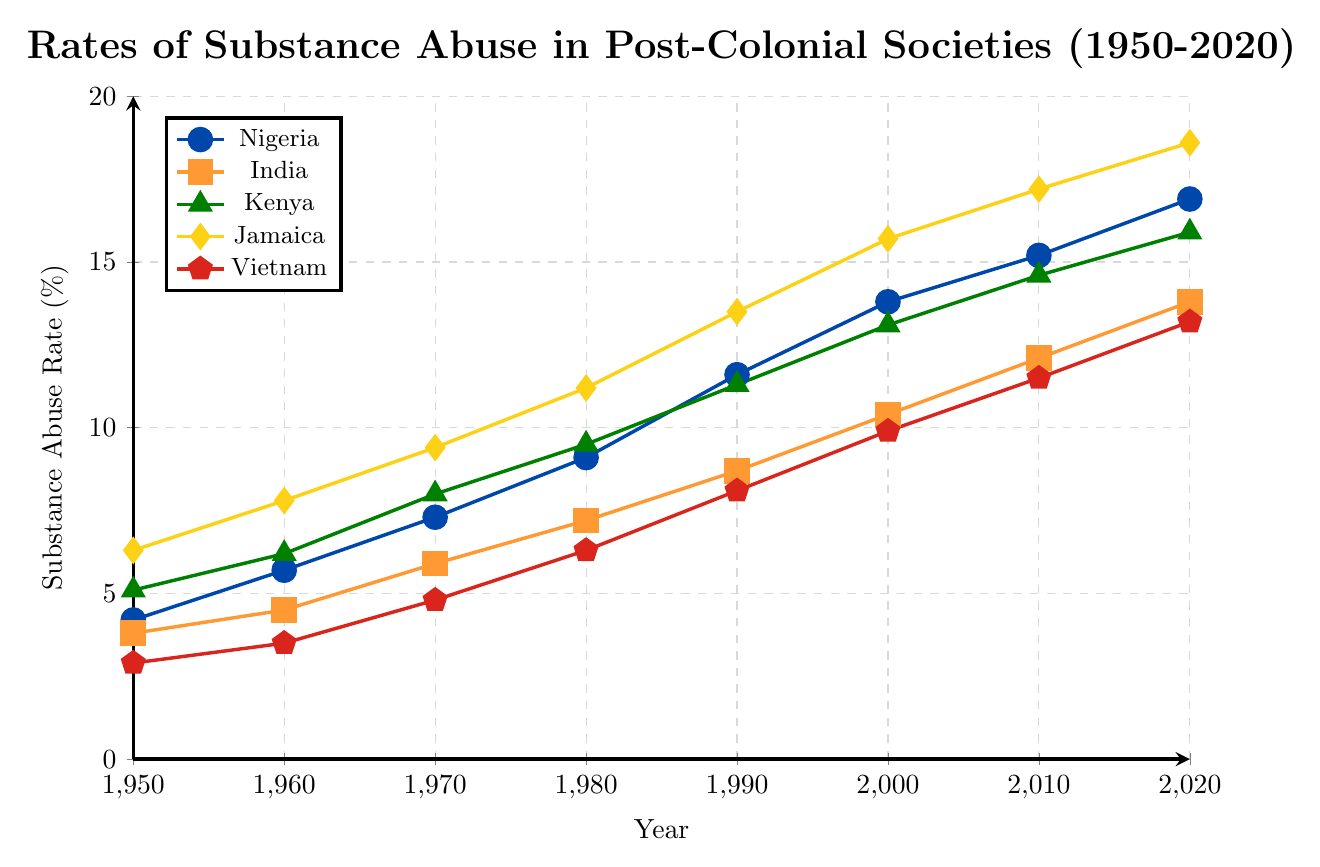What year did Nigeria surpass a substance abuse rate of 10%? Look at the line for Nigeria, indicated by blue circles, and find the year when it crosses the 10% mark on the y-axis. This happens between 1980 and 1990.
Answer: 1990 Which country had the highest substance abuse rate in 1960? Examine the data points for 1960 across all countries. The highest value is represented by the yellow diamond (Jamaica) at 7.8%.
Answer: Jamaica Which country shows the steepest increase in substance abuse rates from 1950 to 2020? Evaluate the slopes of the lines for each country over the entire time period. The line with the steepest incline, indicating the fastest increase, is Jamaica (yellow diamonds).
Answer: Jamaica How much did the substance abuse rate in India increase from 1980 to 2020 compared to Nigeria? Calculate the difference for both countries. For India, it's 13.8% - 7.2% = 6.6%. For Nigeria, it's 16.9% - 9.1% = 7.8%. Compare the two values.
Answer: Nigeria had a higher increase What is the median substance abuse rate in 2000 for all countries? List the 2000 values: 13.8 (Nigeria), 10.4 (India), 13.1 (Kenya), 15.7 (Jamaica), and 9.9 (Vietnam). Order these values and find the median. Ordered: 9.9, 10.4, 13.1, 13.8, 15.7. The median is the middle value, 13.1%.
Answer: 13.1% In what year did Vietnam's substance abuse rate reach 10%? Locate Vietnam's line, indicated by red pentagons, and identify the year when the rate first reaches or exceeds 10% on the y-axis. This happens between 2000 and 2010.
Answer: 2010 By how much did Kenya's substance abuse rate increase from 1950 to 1990? Find the difference between the 1990 and 1950 values for Kenya (green triangles): 11.3% - 5.1% = 6.2%.
Answer: 6.2% Which country had a substance abuse rate closest to 15% in 2010? Look at the data points for 2010 and find the country with the value closest to 15%. Kenya (14.6%), Nigeria (15.2%), Jamaica (17.2%), India (12.1%), and Vietnam (11.5%). The closest is 14.6% (Kenya).
Answer: Kenya Compare the substance abuse rates of Jamaica and India in 1980. Which was higher? Observe the 1980 values for Jamaica (yellow diamonds, 11.2%) and India (orange squares, 7.2%). Jamaica's rate is higher.
Answer: Jamaica had a higher rate What is the average substance abuse rate for Vietnam across all the years provided? Sum the values for Vietnam across all years and divide by the number of data points: (2.9 + 3.5 + 4.8 + 6.3 + 8.1 + 9.9 + 11.5 + 13.2) / 8 = 7.65%.
Answer: 7.65% 